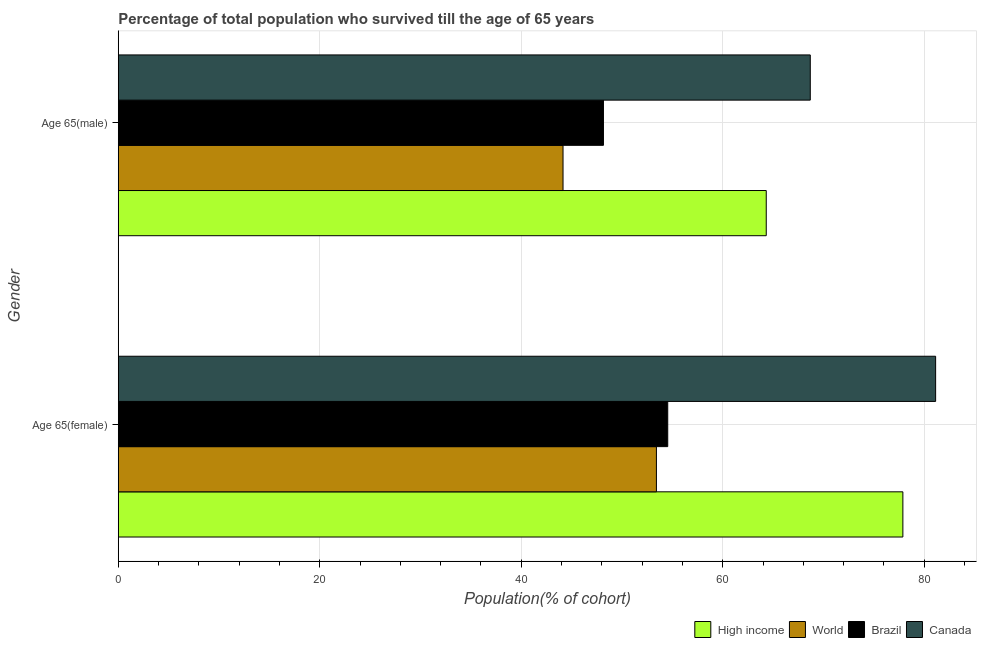How many groups of bars are there?
Provide a succinct answer. 2. Are the number of bars per tick equal to the number of legend labels?
Your response must be concise. Yes. How many bars are there on the 2nd tick from the top?
Your answer should be compact. 4. How many bars are there on the 2nd tick from the bottom?
Give a very brief answer. 4. What is the label of the 1st group of bars from the top?
Ensure brevity in your answer.  Age 65(male). What is the percentage of female population who survived till age of 65 in Canada?
Make the answer very short. 81.14. Across all countries, what is the maximum percentage of female population who survived till age of 65?
Provide a succinct answer. 81.14. Across all countries, what is the minimum percentage of male population who survived till age of 65?
Ensure brevity in your answer.  44.15. What is the total percentage of male population who survived till age of 65 in the graph?
Your answer should be compact. 225.33. What is the difference between the percentage of female population who survived till age of 65 in Canada and that in High income?
Offer a very short reply. 3.25. What is the difference between the percentage of female population who survived till age of 65 in Brazil and the percentage of male population who survived till age of 65 in Canada?
Offer a very short reply. -14.15. What is the average percentage of male population who survived till age of 65 per country?
Your answer should be very brief. 56.33. What is the difference between the percentage of female population who survived till age of 65 and percentage of male population who survived till age of 65 in High income?
Give a very brief answer. 13.56. In how many countries, is the percentage of male population who survived till age of 65 greater than 32 %?
Your response must be concise. 4. What is the ratio of the percentage of male population who survived till age of 65 in Canada to that in Brazil?
Ensure brevity in your answer.  1.43. Is the percentage of female population who survived till age of 65 in High income less than that in Canada?
Offer a terse response. Yes. In how many countries, is the percentage of female population who survived till age of 65 greater than the average percentage of female population who survived till age of 65 taken over all countries?
Ensure brevity in your answer.  2. What does the 1st bar from the top in Age 65(male) represents?
Offer a very short reply. Canada. What does the 2nd bar from the bottom in Age 65(male) represents?
Provide a succinct answer. World. How many bars are there?
Ensure brevity in your answer.  8. Are all the bars in the graph horizontal?
Your answer should be compact. Yes. How many countries are there in the graph?
Your response must be concise. 4. What is the difference between two consecutive major ticks on the X-axis?
Offer a terse response. 20. Are the values on the major ticks of X-axis written in scientific E-notation?
Give a very brief answer. No. Does the graph contain grids?
Your answer should be compact. Yes. How many legend labels are there?
Provide a short and direct response. 4. How are the legend labels stacked?
Offer a very short reply. Horizontal. What is the title of the graph?
Your answer should be very brief. Percentage of total population who survived till the age of 65 years. Does "Canada" appear as one of the legend labels in the graph?
Make the answer very short. Yes. What is the label or title of the X-axis?
Provide a short and direct response. Population(% of cohort). What is the label or title of the Y-axis?
Ensure brevity in your answer.  Gender. What is the Population(% of cohort) in High income in Age 65(female)?
Offer a terse response. 77.88. What is the Population(% of cohort) in World in Age 65(female)?
Offer a terse response. 53.42. What is the Population(% of cohort) in Brazil in Age 65(female)?
Your answer should be very brief. 54.54. What is the Population(% of cohort) of Canada in Age 65(female)?
Offer a very short reply. 81.14. What is the Population(% of cohort) in High income in Age 65(male)?
Your response must be concise. 64.32. What is the Population(% of cohort) in World in Age 65(male)?
Your answer should be compact. 44.15. What is the Population(% of cohort) of Brazil in Age 65(male)?
Provide a short and direct response. 48.16. What is the Population(% of cohort) in Canada in Age 65(male)?
Keep it short and to the point. 68.69. Across all Gender, what is the maximum Population(% of cohort) in High income?
Ensure brevity in your answer.  77.88. Across all Gender, what is the maximum Population(% of cohort) in World?
Your response must be concise. 53.42. Across all Gender, what is the maximum Population(% of cohort) of Brazil?
Offer a terse response. 54.54. Across all Gender, what is the maximum Population(% of cohort) in Canada?
Provide a short and direct response. 81.14. Across all Gender, what is the minimum Population(% of cohort) in High income?
Offer a terse response. 64.32. Across all Gender, what is the minimum Population(% of cohort) of World?
Offer a terse response. 44.15. Across all Gender, what is the minimum Population(% of cohort) in Brazil?
Your response must be concise. 48.16. Across all Gender, what is the minimum Population(% of cohort) in Canada?
Your answer should be compact. 68.69. What is the total Population(% of cohort) of High income in the graph?
Offer a very short reply. 142.21. What is the total Population(% of cohort) in World in the graph?
Ensure brevity in your answer.  97.57. What is the total Population(% of cohort) of Brazil in the graph?
Ensure brevity in your answer.  102.7. What is the total Population(% of cohort) in Canada in the graph?
Make the answer very short. 149.83. What is the difference between the Population(% of cohort) in High income in Age 65(female) and that in Age 65(male)?
Offer a terse response. 13.56. What is the difference between the Population(% of cohort) of World in Age 65(female) and that in Age 65(male)?
Your answer should be very brief. 9.27. What is the difference between the Population(% of cohort) of Brazil in Age 65(female) and that in Age 65(male)?
Your answer should be very brief. 6.38. What is the difference between the Population(% of cohort) in Canada in Age 65(female) and that in Age 65(male)?
Ensure brevity in your answer.  12.44. What is the difference between the Population(% of cohort) of High income in Age 65(female) and the Population(% of cohort) of World in Age 65(male)?
Your answer should be very brief. 33.74. What is the difference between the Population(% of cohort) in High income in Age 65(female) and the Population(% of cohort) in Brazil in Age 65(male)?
Keep it short and to the point. 29.72. What is the difference between the Population(% of cohort) of High income in Age 65(female) and the Population(% of cohort) of Canada in Age 65(male)?
Give a very brief answer. 9.19. What is the difference between the Population(% of cohort) of World in Age 65(female) and the Population(% of cohort) of Brazil in Age 65(male)?
Ensure brevity in your answer.  5.26. What is the difference between the Population(% of cohort) of World in Age 65(female) and the Population(% of cohort) of Canada in Age 65(male)?
Ensure brevity in your answer.  -15.27. What is the difference between the Population(% of cohort) in Brazil in Age 65(female) and the Population(% of cohort) in Canada in Age 65(male)?
Your answer should be very brief. -14.15. What is the average Population(% of cohort) of High income per Gender?
Provide a succinct answer. 71.1. What is the average Population(% of cohort) in World per Gender?
Ensure brevity in your answer.  48.78. What is the average Population(% of cohort) in Brazil per Gender?
Provide a short and direct response. 51.35. What is the average Population(% of cohort) of Canada per Gender?
Ensure brevity in your answer.  74.91. What is the difference between the Population(% of cohort) of High income and Population(% of cohort) of World in Age 65(female)?
Your answer should be very brief. 24.46. What is the difference between the Population(% of cohort) of High income and Population(% of cohort) of Brazil in Age 65(female)?
Your answer should be compact. 23.34. What is the difference between the Population(% of cohort) in High income and Population(% of cohort) in Canada in Age 65(female)?
Make the answer very short. -3.25. What is the difference between the Population(% of cohort) of World and Population(% of cohort) of Brazil in Age 65(female)?
Give a very brief answer. -1.12. What is the difference between the Population(% of cohort) in World and Population(% of cohort) in Canada in Age 65(female)?
Ensure brevity in your answer.  -27.72. What is the difference between the Population(% of cohort) in Brazil and Population(% of cohort) in Canada in Age 65(female)?
Give a very brief answer. -26.59. What is the difference between the Population(% of cohort) of High income and Population(% of cohort) of World in Age 65(male)?
Your answer should be very brief. 20.17. What is the difference between the Population(% of cohort) of High income and Population(% of cohort) of Brazil in Age 65(male)?
Give a very brief answer. 16.16. What is the difference between the Population(% of cohort) of High income and Population(% of cohort) of Canada in Age 65(male)?
Your answer should be very brief. -4.37. What is the difference between the Population(% of cohort) in World and Population(% of cohort) in Brazil in Age 65(male)?
Keep it short and to the point. -4.01. What is the difference between the Population(% of cohort) of World and Population(% of cohort) of Canada in Age 65(male)?
Your answer should be compact. -24.55. What is the difference between the Population(% of cohort) in Brazil and Population(% of cohort) in Canada in Age 65(male)?
Your answer should be very brief. -20.53. What is the ratio of the Population(% of cohort) in High income in Age 65(female) to that in Age 65(male)?
Provide a short and direct response. 1.21. What is the ratio of the Population(% of cohort) of World in Age 65(female) to that in Age 65(male)?
Make the answer very short. 1.21. What is the ratio of the Population(% of cohort) in Brazil in Age 65(female) to that in Age 65(male)?
Provide a succinct answer. 1.13. What is the ratio of the Population(% of cohort) in Canada in Age 65(female) to that in Age 65(male)?
Ensure brevity in your answer.  1.18. What is the difference between the highest and the second highest Population(% of cohort) in High income?
Offer a very short reply. 13.56. What is the difference between the highest and the second highest Population(% of cohort) of World?
Keep it short and to the point. 9.27. What is the difference between the highest and the second highest Population(% of cohort) in Brazil?
Keep it short and to the point. 6.38. What is the difference between the highest and the second highest Population(% of cohort) in Canada?
Your response must be concise. 12.44. What is the difference between the highest and the lowest Population(% of cohort) in High income?
Give a very brief answer. 13.56. What is the difference between the highest and the lowest Population(% of cohort) of World?
Offer a terse response. 9.27. What is the difference between the highest and the lowest Population(% of cohort) of Brazil?
Offer a terse response. 6.38. What is the difference between the highest and the lowest Population(% of cohort) of Canada?
Keep it short and to the point. 12.44. 